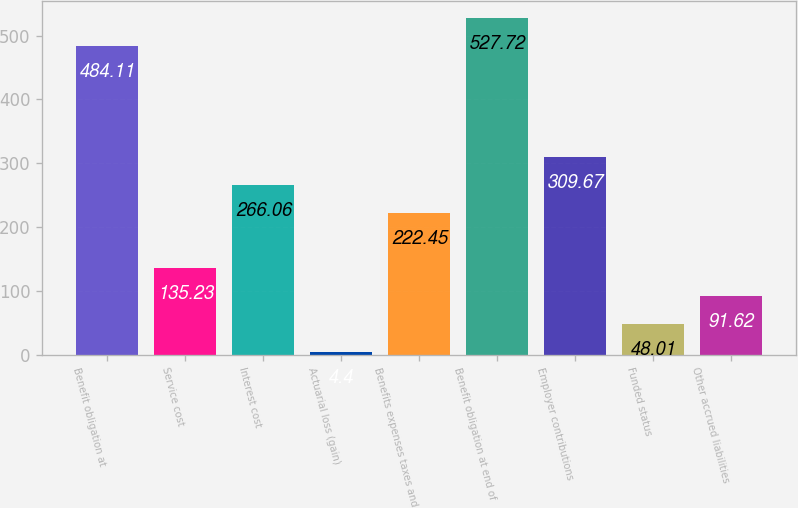Convert chart to OTSL. <chart><loc_0><loc_0><loc_500><loc_500><bar_chart><fcel>Benefit obligation at<fcel>Service cost<fcel>Interest cost<fcel>Actuarial loss (gain)<fcel>Benefits expenses taxes and<fcel>Benefit obligation at end of<fcel>Employer contributions<fcel>Funded status<fcel>Other accrued liabilities<nl><fcel>484.11<fcel>135.23<fcel>266.06<fcel>4.4<fcel>222.45<fcel>527.72<fcel>309.67<fcel>48.01<fcel>91.62<nl></chart> 